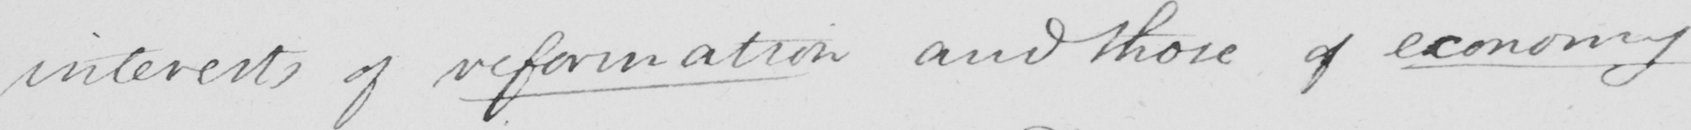Can you tell me what this handwritten text says? interests of reformation and those of economy 